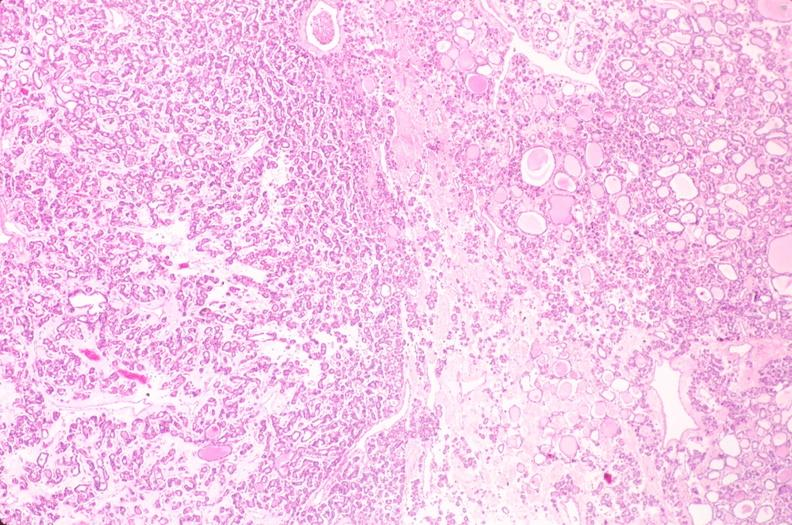where is this part in the figure?
Answer the question using a single word or phrase. Endocrine system 